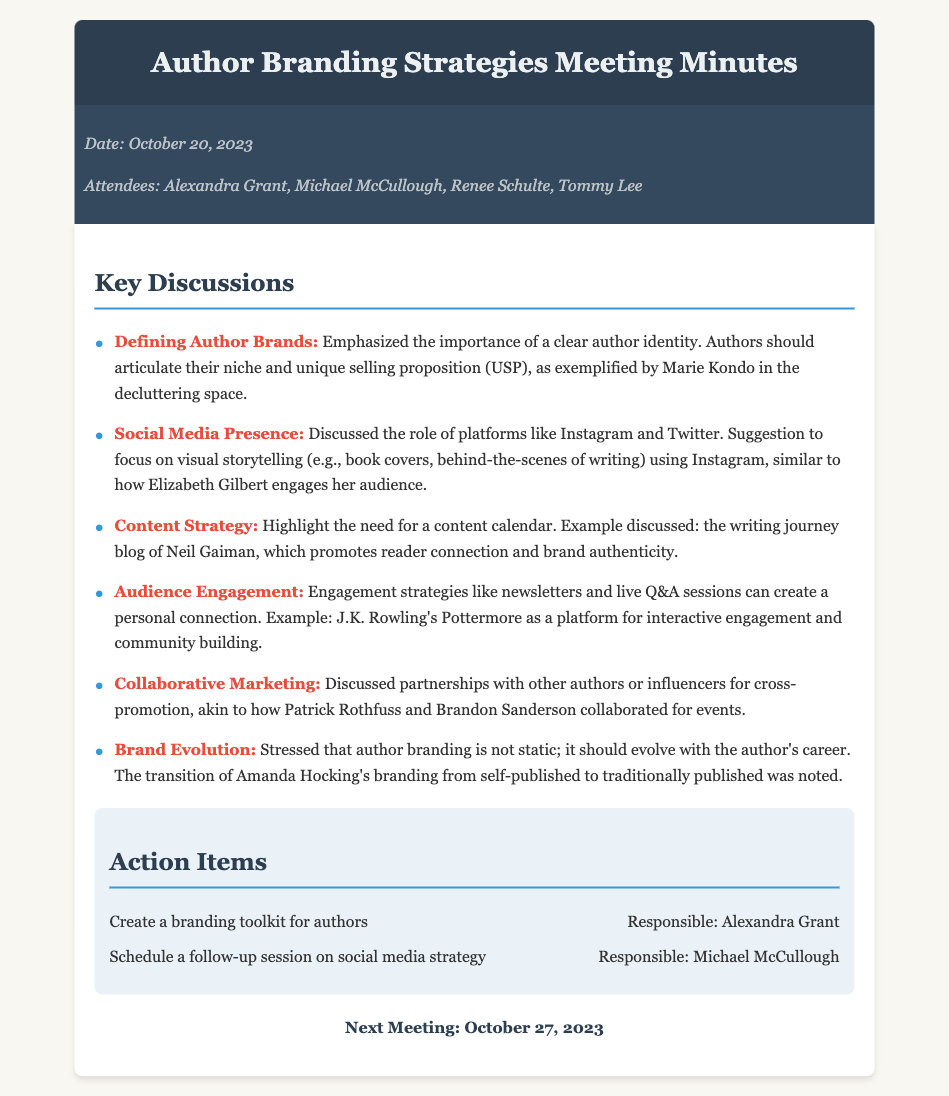what is the date of the meeting? The date of the meeting is explicitly stated in the document.
Answer: October 20, 2023 who is responsible for creating a branding toolkit for authors? This information is provided in the action items section of the document.
Answer: Alexandra Grant what platform was suggested for visual storytelling? The discussion mentions a specific platform for visual storytelling in the context of author branding.
Answer: Instagram which author was referenced as an example for defining author brands? The document provides a specific example to illustrate the concept of author branding.
Answer: Marie Kondo what was emphasized about author branding in the discussion? The importance of branding is mentioned throughout the document, indicating its dynamic nature.
Answer: It should evolve with the author's career which engagement strategy involved newsletters and live Q&A sessions? This specific strategy is discussed in the context of audience engagement in the document.
Answer: Audience Engagement who was responsible for scheduling a follow-up session on social media strategy? The meeting minutes list the individual responsible for this action item.
Answer: Michael McCullough 